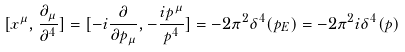Convert formula to latex. <formula><loc_0><loc_0><loc_500><loc_500>[ x ^ { \mu } , \frac { \partial _ { \mu } } { \partial ^ { 4 } } ] = [ - i \frac { \partial } { \partial p _ { \mu } } , - \frac { i p ^ { \mu } } { p ^ { 4 } } ] = - 2 \pi ^ { 2 } \delta ^ { 4 } ( p _ { E } ) = - 2 \pi ^ { 2 } i \delta ^ { 4 } ( p )</formula> 